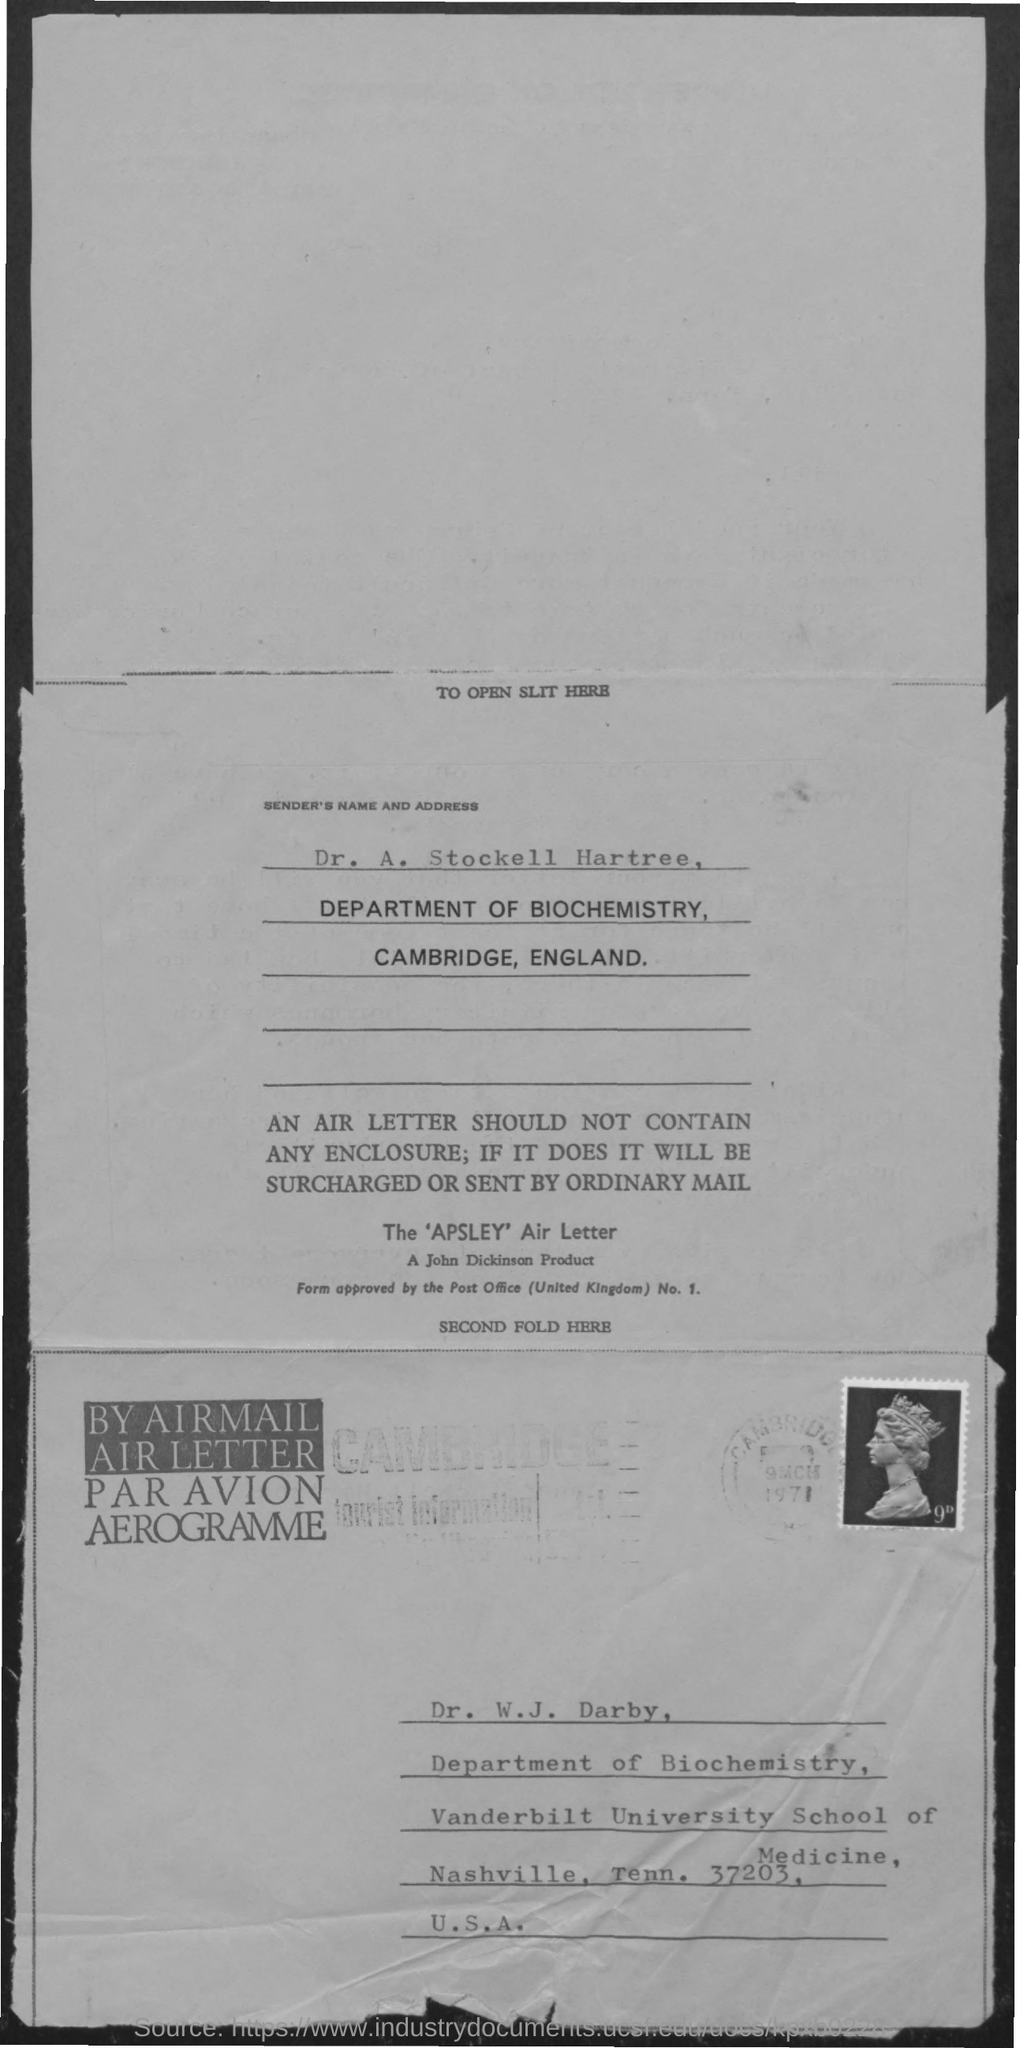What is the senders name mentioned ?
Ensure brevity in your answer.  Dr. A. stockell hartree. To which department dr, a. stockell hartree belongs to ?
Your answer should be compact. Department of Biochemistry. 